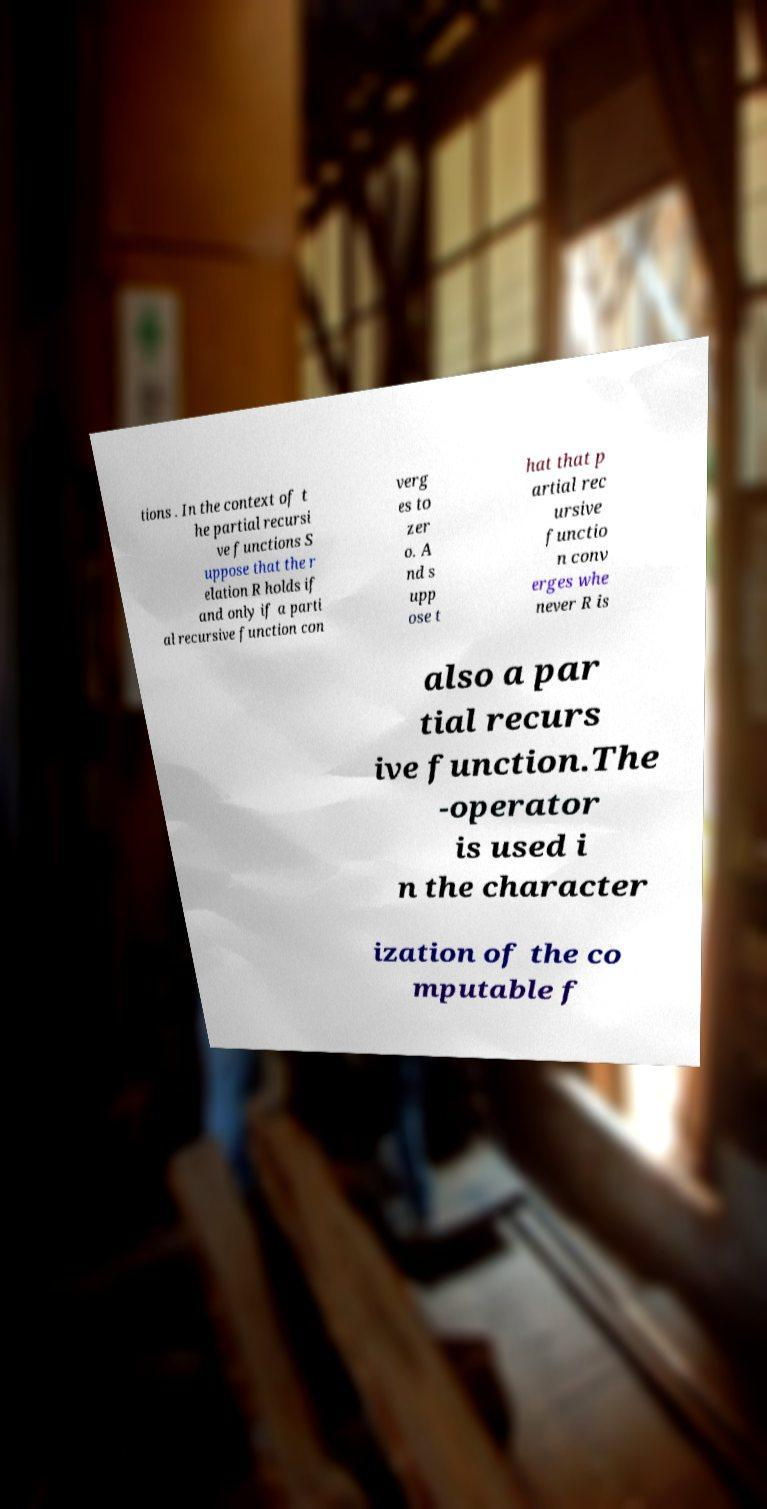There's text embedded in this image that I need extracted. Can you transcribe it verbatim? tions . In the context of t he partial recursi ve functions S uppose that the r elation R holds if and only if a parti al recursive function con verg es to zer o. A nd s upp ose t hat that p artial rec ursive functio n conv erges whe never R is also a par tial recurs ive function.The -operator is used i n the character ization of the co mputable f 